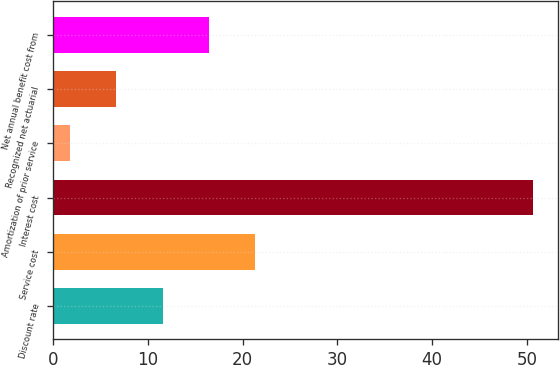Convert chart to OTSL. <chart><loc_0><loc_0><loc_500><loc_500><bar_chart><fcel>Discount rate<fcel>Service cost<fcel>Interest cost<fcel>Amortization of prior service<fcel>Recognized net actuarial<fcel>Net annual benefit cost from<nl><fcel>11.58<fcel>21.36<fcel>50.7<fcel>1.8<fcel>6.69<fcel>16.47<nl></chart> 